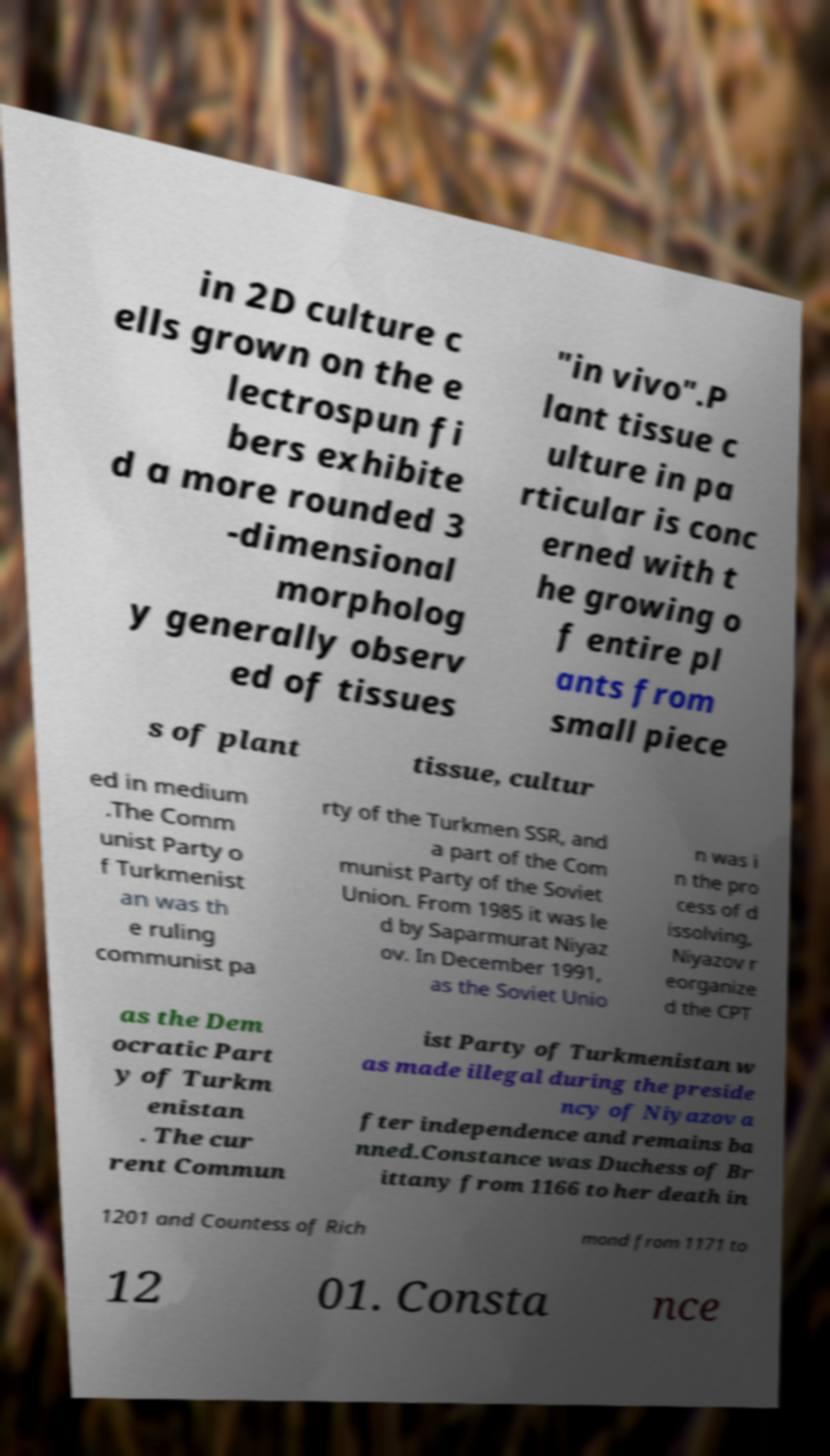Can you accurately transcribe the text from the provided image for me? in 2D culture c ells grown on the e lectrospun fi bers exhibite d a more rounded 3 -dimensional morpholog y generally observ ed of tissues "in vivo".P lant tissue c ulture in pa rticular is conc erned with t he growing o f entire pl ants from small piece s of plant tissue, cultur ed in medium .The Comm unist Party o f Turkmenist an was th e ruling communist pa rty of the Turkmen SSR, and a part of the Com munist Party of the Soviet Union. From 1985 it was le d by Saparmurat Niyaz ov. In December 1991, as the Soviet Unio n was i n the pro cess of d issolving, Niyazov r eorganize d the CPT as the Dem ocratic Part y of Turkm enistan . The cur rent Commun ist Party of Turkmenistan w as made illegal during the preside ncy of Niyazov a fter independence and remains ba nned.Constance was Duchess of Br ittany from 1166 to her death in 1201 and Countess of Rich mond from 1171 to 12 01. Consta nce 